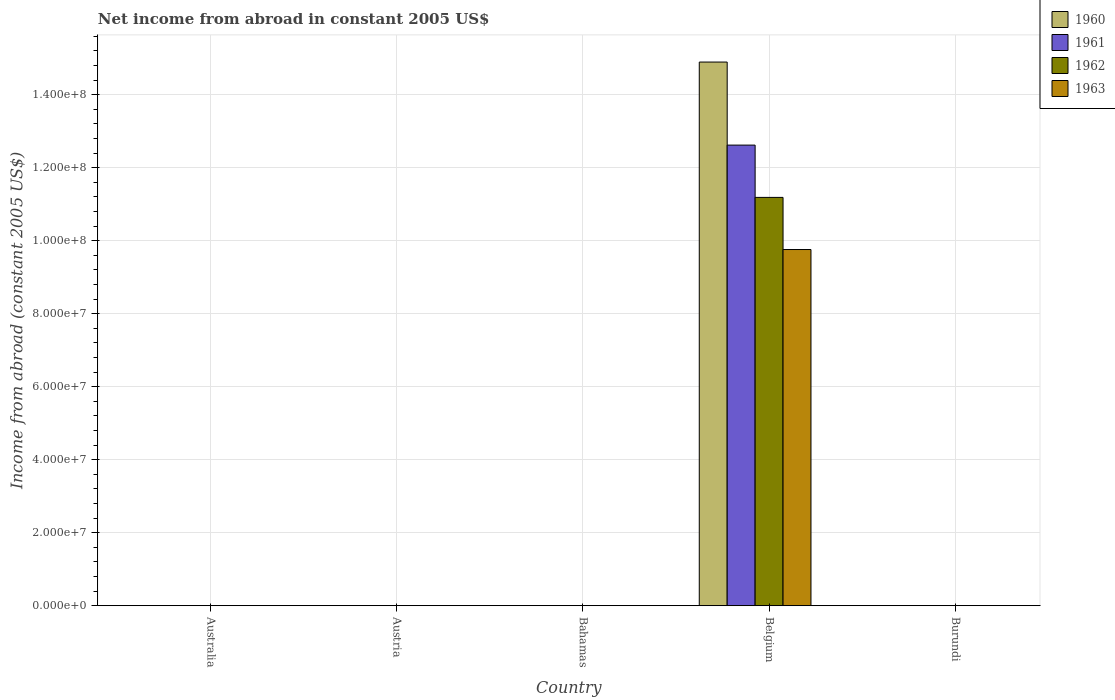How many different coloured bars are there?
Ensure brevity in your answer.  4. Are the number of bars per tick equal to the number of legend labels?
Your response must be concise. No. Are the number of bars on each tick of the X-axis equal?
Provide a short and direct response. No. How many bars are there on the 3rd tick from the left?
Make the answer very short. 0. How many bars are there on the 3rd tick from the right?
Give a very brief answer. 0. In how many cases, is the number of bars for a given country not equal to the number of legend labels?
Offer a terse response. 4. What is the net income from abroad in 1962 in Bahamas?
Offer a terse response. 0. Across all countries, what is the maximum net income from abroad in 1962?
Give a very brief answer. 1.12e+08. Across all countries, what is the minimum net income from abroad in 1963?
Offer a very short reply. 0. What is the total net income from abroad in 1962 in the graph?
Offer a terse response. 1.12e+08. What is the difference between the net income from abroad in 1961 in Belgium and the net income from abroad in 1960 in Australia?
Your answer should be very brief. 1.26e+08. What is the average net income from abroad in 1962 per country?
Provide a succinct answer. 2.24e+07. What is the difference between the net income from abroad of/in 1963 and net income from abroad of/in 1961 in Belgium?
Give a very brief answer. -2.86e+07. What is the difference between the highest and the lowest net income from abroad in 1963?
Provide a short and direct response. 9.76e+07. In how many countries, is the net income from abroad in 1961 greater than the average net income from abroad in 1961 taken over all countries?
Provide a short and direct response. 1. How many bars are there?
Offer a very short reply. 4. What is the difference between two consecutive major ticks on the Y-axis?
Provide a short and direct response. 2.00e+07. Does the graph contain any zero values?
Keep it short and to the point. Yes. Does the graph contain grids?
Give a very brief answer. Yes. What is the title of the graph?
Give a very brief answer. Net income from abroad in constant 2005 US$. What is the label or title of the Y-axis?
Ensure brevity in your answer.  Income from abroad (constant 2005 US$). What is the Income from abroad (constant 2005 US$) in 1961 in Australia?
Your answer should be compact. 0. What is the Income from abroad (constant 2005 US$) in 1962 in Australia?
Make the answer very short. 0. What is the Income from abroad (constant 2005 US$) of 1963 in Australia?
Your answer should be very brief. 0. What is the Income from abroad (constant 2005 US$) of 1962 in Austria?
Provide a succinct answer. 0. What is the Income from abroad (constant 2005 US$) of 1963 in Austria?
Your response must be concise. 0. What is the Income from abroad (constant 2005 US$) of 1963 in Bahamas?
Your answer should be compact. 0. What is the Income from abroad (constant 2005 US$) in 1960 in Belgium?
Keep it short and to the point. 1.49e+08. What is the Income from abroad (constant 2005 US$) in 1961 in Belgium?
Ensure brevity in your answer.  1.26e+08. What is the Income from abroad (constant 2005 US$) of 1962 in Belgium?
Your answer should be compact. 1.12e+08. What is the Income from abroad (constant 2005 US$) of 1963 in Belgium?
Offer a very short reply. 9.76e+07. What is the Income from abroad (constant 2005 US$) in 1960 in Burundi?
Ensure brevity in your answer.  0. What is the Income from abroad (constant 2005 US$) in 1961 in Burundi?
Give a very brief answer. 0. What is the Income from abroad (constant 2005 US$) in 1962 in Burundi?
Provide a succinct answer. 0. Across all countries, what is the maximum Income from abroad (constant 2005 US$) in 1960?
Your response must be concise. 1.49e+08. Across all countries, what is the maximum Income from abroad (constant 2005 US$) in 1961?
Offer a terse response. 1.26e+08. Across all countries, what is the maximum Income from abroad (constant 2005 US$) in 1962?
Offer a terse response. 1.12e+08. Across all countries, what is the maximum Income from abroad (constant 2005 US$) of 1963?
Provide a short and direct response. 9.76e+07. Across all countries, what is the minimum Income from abroad (constant 2005 US$) of 1961?
Your response must be concise. 0. Across all countries, what is the minimum Income from abroad (constant 2005 US$) in 1963?
Give a very brief answer. 0. What is the total Income from abroad (constant 2005 US$) of 1960 in the graph?
Make the answer very short. 1.49e+08. What is the total Income from abroad (constant 2005 US$) of 1961 in the graph?
Provide a succinct answer. 1.26e+08. What is the total Income from abroad (constant 2005 US$) in 1962 in the graph?
Give a very brief answer. 1.12e+08. What is the total Income from abroad (constant 2005 US$) of 1963 in the graph?
Offer a very short reply. 9.76e+07. What is the average Income from abroad (constant 2005 US$) in 1960 per country?
Give a very brief answer. 2.98e+07. What is the average Income from abroad (constant 2005 US$) in 1961 per country?
Offer a very short reply. 2.52e+07. What is the average Income from abroad (constant 2005 US$) in 1962 per country?
Your response must be concise. 2.24e+07. What is the average Income from abroad (constant 2005 US$) of 1963 per country?
Keep it short and to the point. 1.95e+07. What is the difference between the Income from abroad (constant 2005 US$) of 1960 and Income from abroad (constant 2005 US$) of 1961 in Belgium?
Your answer should be compact. 2.27e+07. What is the difference between the Income from abroad (constant 2005 US$) in 1960 and Income from abroad (constant 2005 US$) in 1962 in Belgium?
Ensure brevity in your answer.  3.71e+07. What is the difference between the Income from abroad (constant 2005 US$) in 1960 and Income from abroad (constant 2005 US$) in 1963 in Belgium?
Make the answer very short. 5.14e+07. What is the difference between the Income from abroad (constant 2005 US$) of 1961 and Income from abroad (constant 2005 US$) of 1962 in Belgium?
Make the answer very short. 1.43e+07. What is the difference between the Income from abroad (constant 2005 US$) of 1961 and Income from abroad (constant 2005 US$) of 1963 in Belgium?
Ensure brevity in your answer.  2.86e+07. What is the difference between the Income from abroad (constant 2005 US$) of 1962 and Income from abroad (constant 2005 US$) of 1963 in Belgium?
Provide a succinct answer. 1.43e+07. What is the difference between the highest and the lowest Income from abroad (constant 2005 US$) in 1960?
Make the answer very short. 1.49e+08. What is the difference between the highest and the lowest Income from abroad (constant 2005 US$) of 1961?
Give a very brief answer. 1.26e+08. What is the difference between the highest and the lowest Income from abroad (constant 2005 US$) of 1962?
Your answer should be very brief. 1.12e+08. What is the difference between the highest and the lowest Income from abroad (constant 2005 US$) in 1963?
Keep it short and to the point. 9.76e+07. 